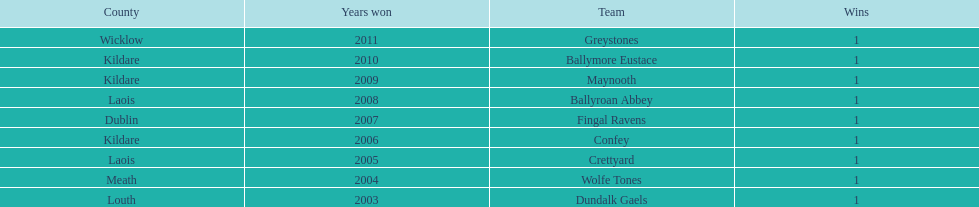Which county had the most number of wins? Kildare. 